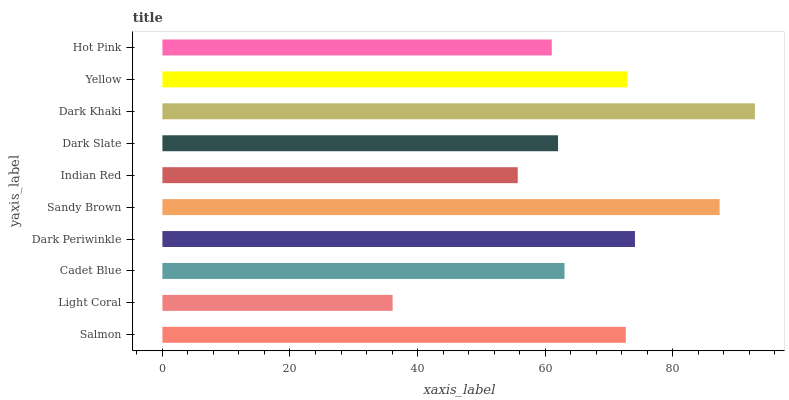Is Light Coral the minimum?
Answer yes or no. Yes. Is Dark Khaki the maximum?
Answer yes or no. Yes. Is Cadet Blue the minimum?
Answer yes or no. No. Is Cadet Blue the maximum?
Answer yes or no. No. Is Cadet Blue greater than Light Coral?
Answer yes or no. Yes. Is Light Coral less than Cadet Blue?
Answer yes or no. Yes. Is Light Coral greater than Cadet Blue?
Answer yes or no. No. Is Cadet Blue less than Light Coral?
Answer yes or no. No. Is Salmon the high median?
Answer yes or no. Yes. Is Cadet Blue the low median?
Answer yes or no. Yes. Is Hot Pink the high median?
Answer yes or no. No. Is Dark Periwinkle the low median?
Answer yes or no. No. 